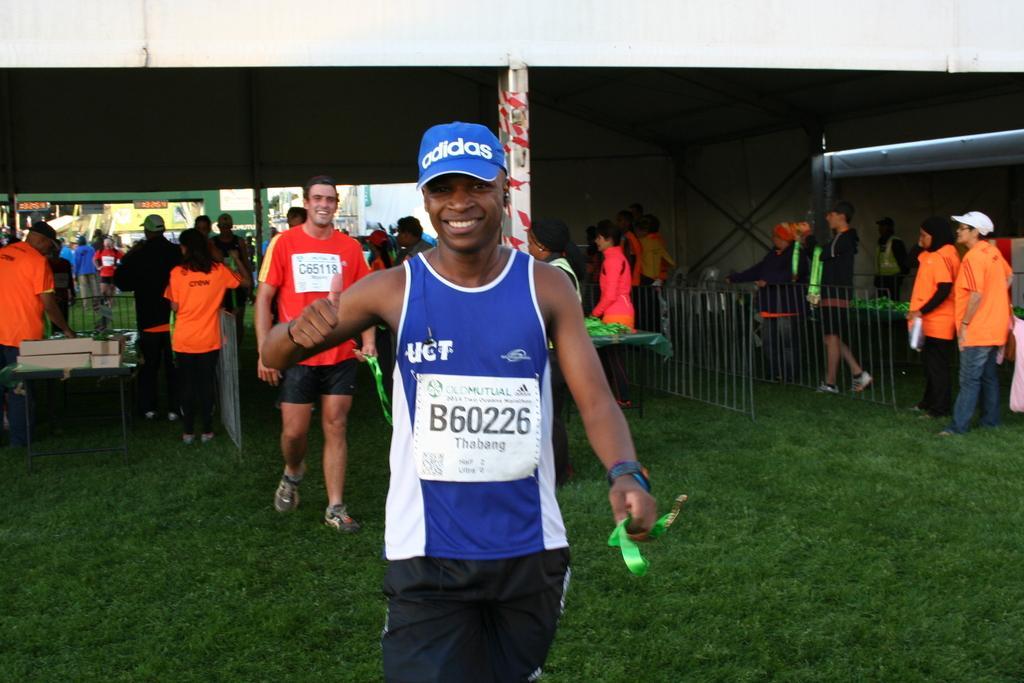Describe this image in one or two sentences. In this image there is a man in the middle standing on the ground by keeping his thumbs up. In the background there are few other people standing in the queue. On the right side there are few people walking on the ground in between the railings. On the ground there is grass. 